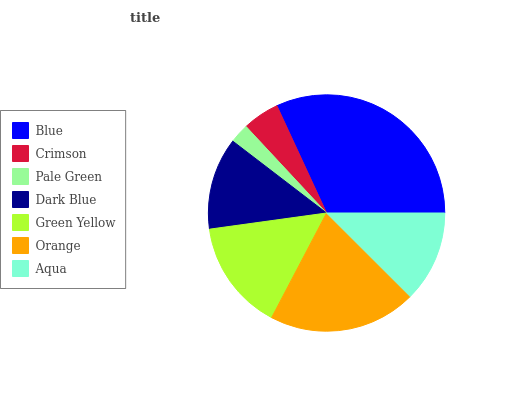Is Pale Green the minimum?
Answer yes or no. Yes. Is Blue the maximum?
Answer yes or no. Yes. Is Crimson the minimum?
Answer yes or no. No. Is Crimson the maximum?
Answer yes or no. No. Is Blue greater than Crimson?
Answer yes or no. Yes. Is Crimson less than Blue?
Answer yes or no. Yes. Is Crimson greater than Blue?
Answer yes or no. No. Is Blue less than Crimson?
Answer yes or no. No. Is Dark Blue the high median?
Answer yes or no. Yes. Is Dark Blue the low median?
Answer yes or no. Yes. Is Green Yellow the high median?
Answer yes or no. No. Is Green Yellow the low median?
Answer yes or no. No. 